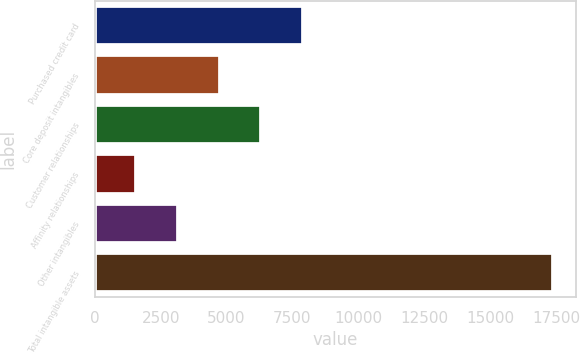Convert chart to OTSL. <chart><loc_0><loc_0><loc_500><loc_500><bar_chart><fcel>Purchased credit card<fcel>Core deposit intangibles<fcel>Customer relationships<fcel>Affinity relationships<fcel>Other intangibles<fcel>Total intangible assets<nl><fcel>7903.8<fcel>4739.4<fcel>6321.6<fcel>1575<fcel>3157.2<fcel>17397<nl></chart> 